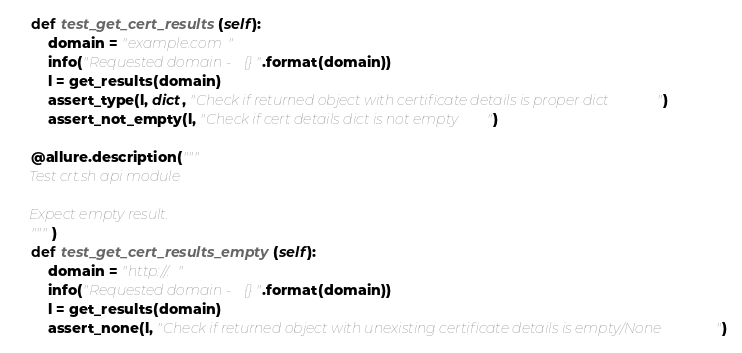<code> <loc_0><loc_0><loc_500><loc_500><_Python_>    def test_get_cert_results(self):
        domain = "example.com"
        info("Requested domain - {}".format(domain))
        l = get_results(domain)
        assert_type(l, dict, "Check if returned object with certificate details is proper dict")
        assert_not_empty(l, "Check if cert details dict is not empty")

    @allure.description("""
    Test crt.sh api module

    Expect empty result.
    """)
    def test_get_cert_results_empty(self):
        domain = "http://."
        info("Requested domain - {}".format(domain))
        l = get_results(domain)
        assert_none(l, "Check if returned object with unexisting certificate details is empty/None")</code> 